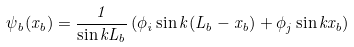<formula> <loc_0><loc_0><loc_500><loc_500>\psi _ { b } ( x _ { b } ) = \frac { 1 } { \sin k L _ { b } } \left ( \phi _ { i } \sin k ( L _ { b } - x _ { b } ) + \phi _ { j } \sin k x _ { b } \right )</formula> 